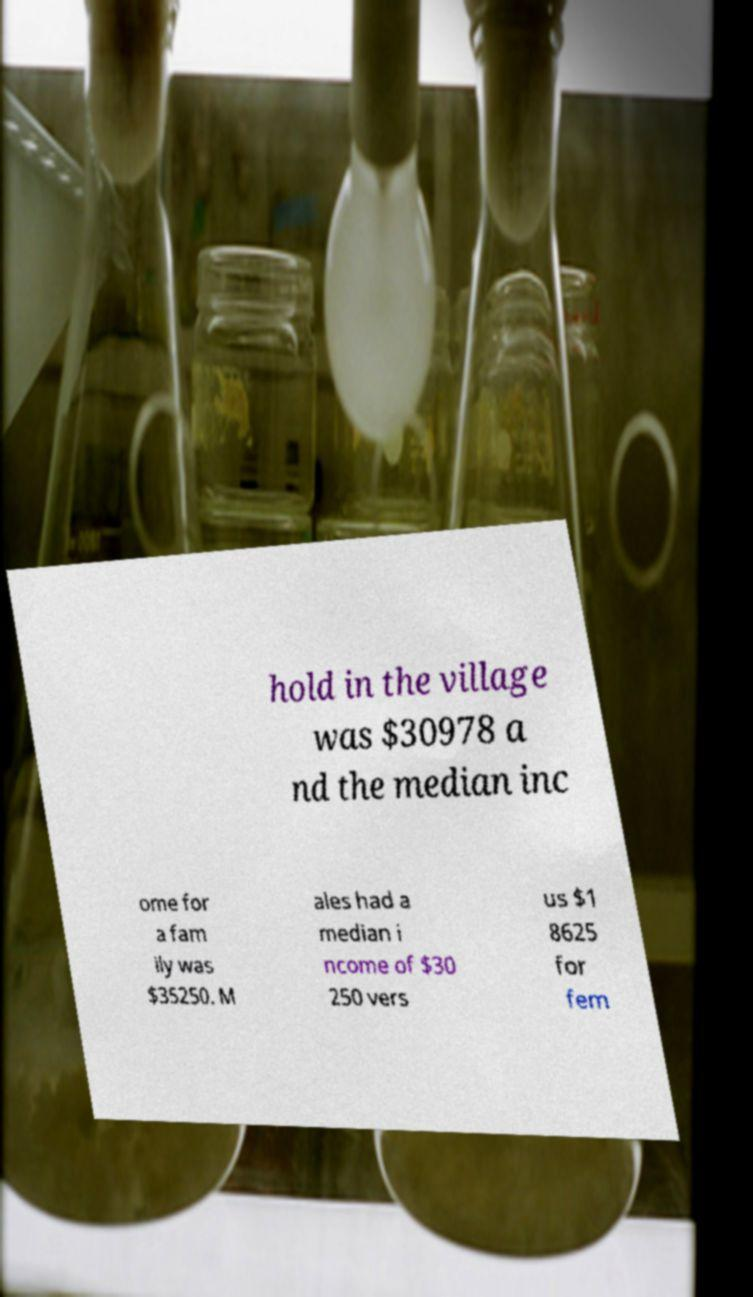Please identify and transcribe the text found in this image. hold in the village was $30978 a nd the median inc ome for a fam ily was $35250. M ales had a median i ncome of $30 250 vers us $1 8625 for fem 